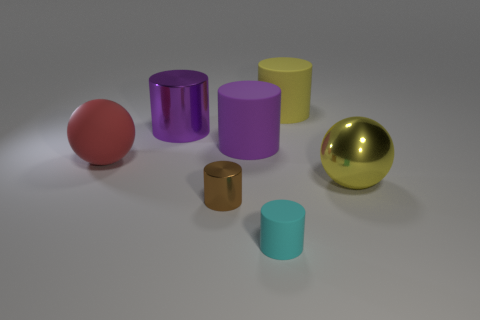Subtract all cyan cylinders. How many cylinders are left? 4 Subtract all cyan cylinders. How many cylinders are left? 4 Subtract all blue cylinders. Subtract all brown blocks. How many cylinders are left? 5 Add 2 yellow objects. How many objects exist? 9 Subtract all balls. How many objects are left? 5 Subtract 0 gray cylinders. How many objects are left? 7 Subtract all green metallic cubes. Subtract all large purple rubber cylinders. How many objects are left? 6 Add 3 brown metallic cylinders. How many brown metallic cylinders are left? 4 Add 5 large red spheres. How many large red spheres exist? 6 